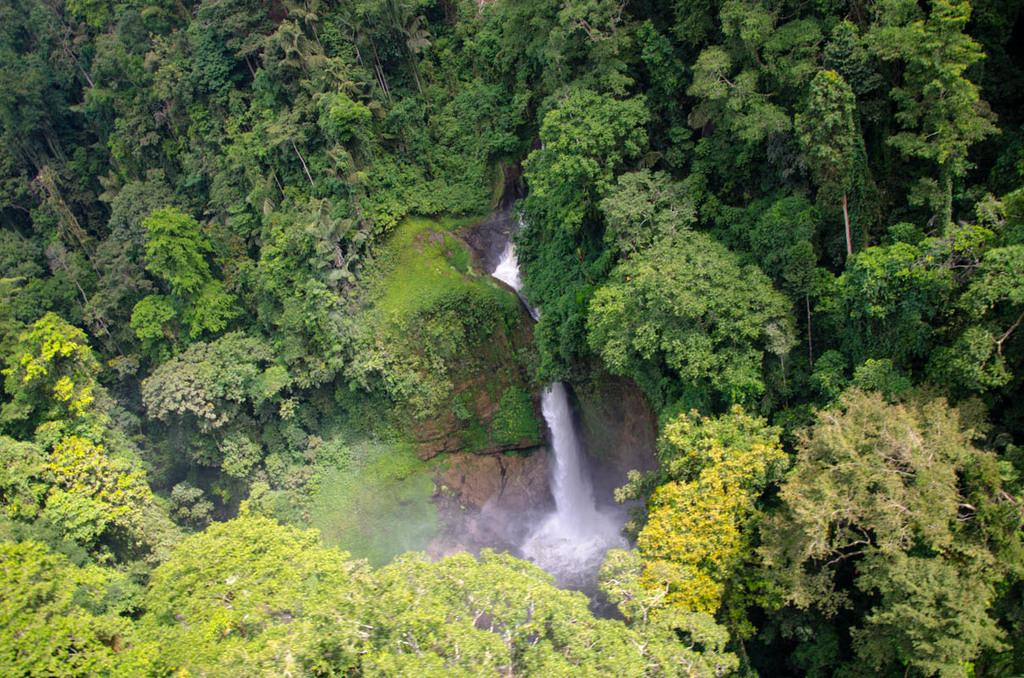What is the main feature of the image? There is a waterfall in the image. What can be seen around the waterfall? The waterfall is surrounded by many huge trees. How many snakes are slithering around the waterfall in the image? There are no snakes visible in the image; it only features a waterfall surrounded by huge trees. What type of wood is used to build the bridge over the waterfall in the image? There is no bridge present in the image, so it is not possible to determine the type of wood used. 